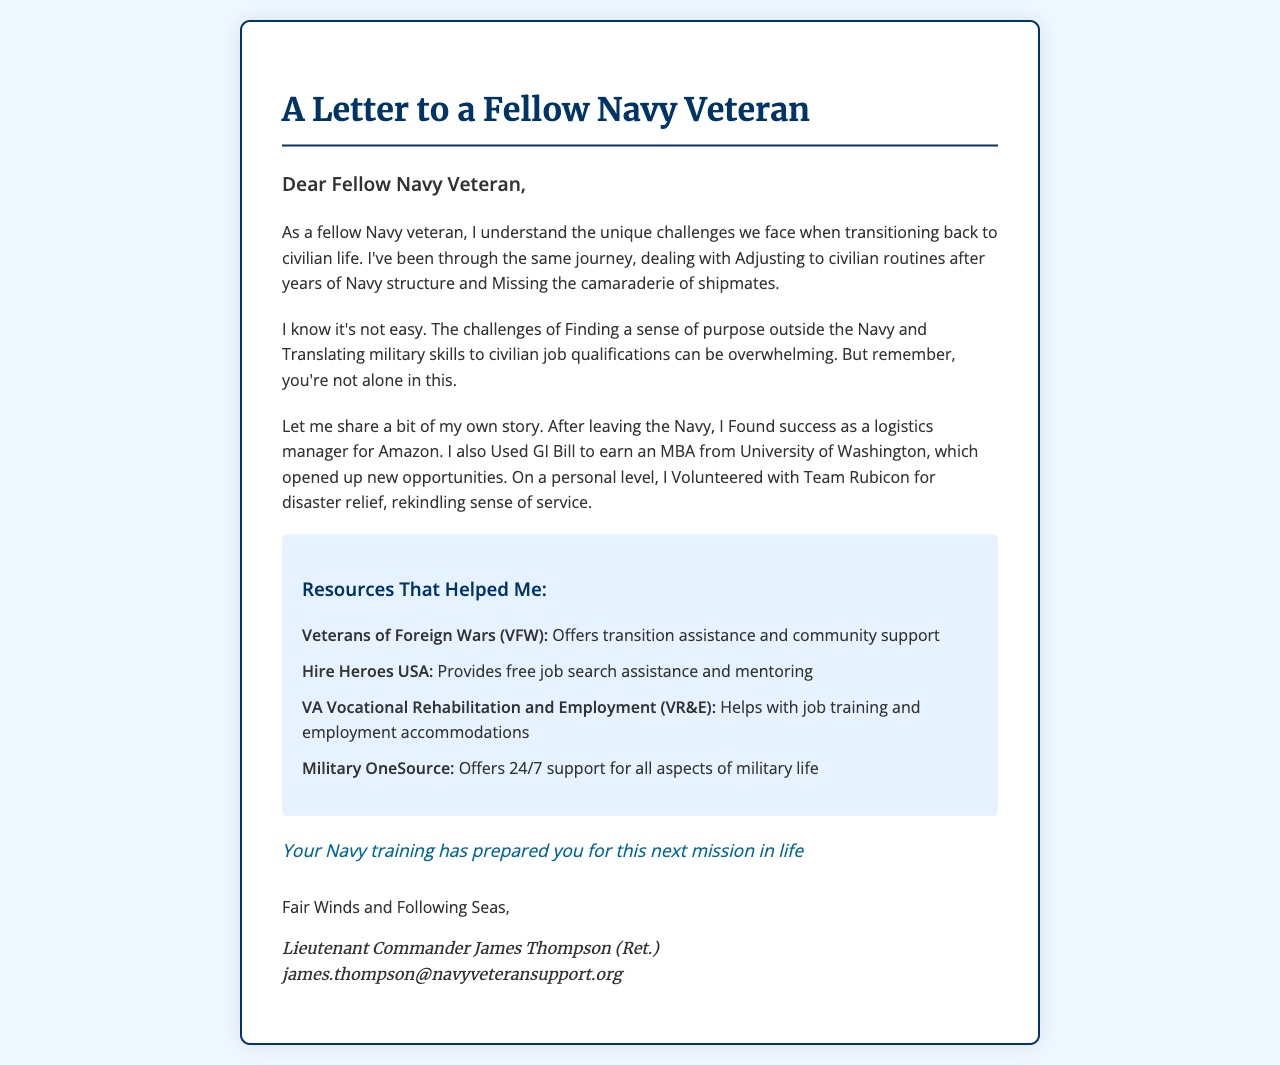What is the name of the sender? The sender's name is mentioned at the end of the letter.
Answer: Lieutenant Commander James Thompson (Ret.) What resources are mentioned for support? The letter lists specific organizations that provide assistance to veterans.
Answer: VFW, Hire Heroes USA, VA Vocational Rehabilitation and Employment, Military OneSource What personal success story is shared? The letter includes a personal accomplishment related to the sender's career and education.
Answer: Found success as a logistics manager for Amazon What encouragement phrase is included? The letter contains motivational words intended to inspire the recipient.
Answer: Your Navy training has prepared you for this next mission in life What shared experience is highlighted in the letter? The letter discusses a common difficulty faced by veterans adjusting to civilian life.
Answer: Missing the camaraderie of shipmates 